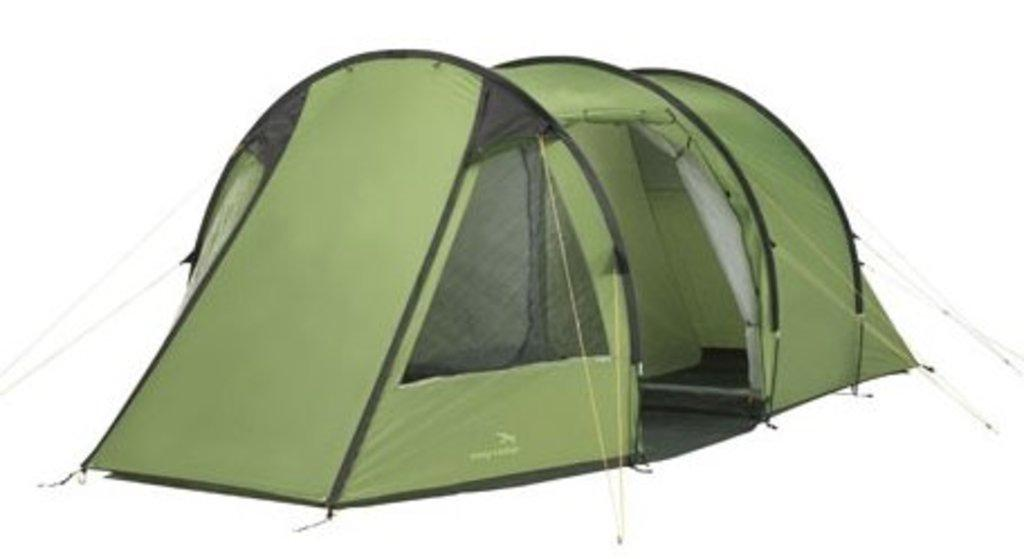What is the main subject of the image? There is a tent in the image. Where is the tent located in the image? The tent is in the center of the image. What color is the tent? The tent is red in color. What type of carriage can be seen pulling the tent in the image? There is no carriage present in the image; it only features a tent. In which country is the scene from the image taking place? The image does not provide any information about the country where the scene is taking place. 